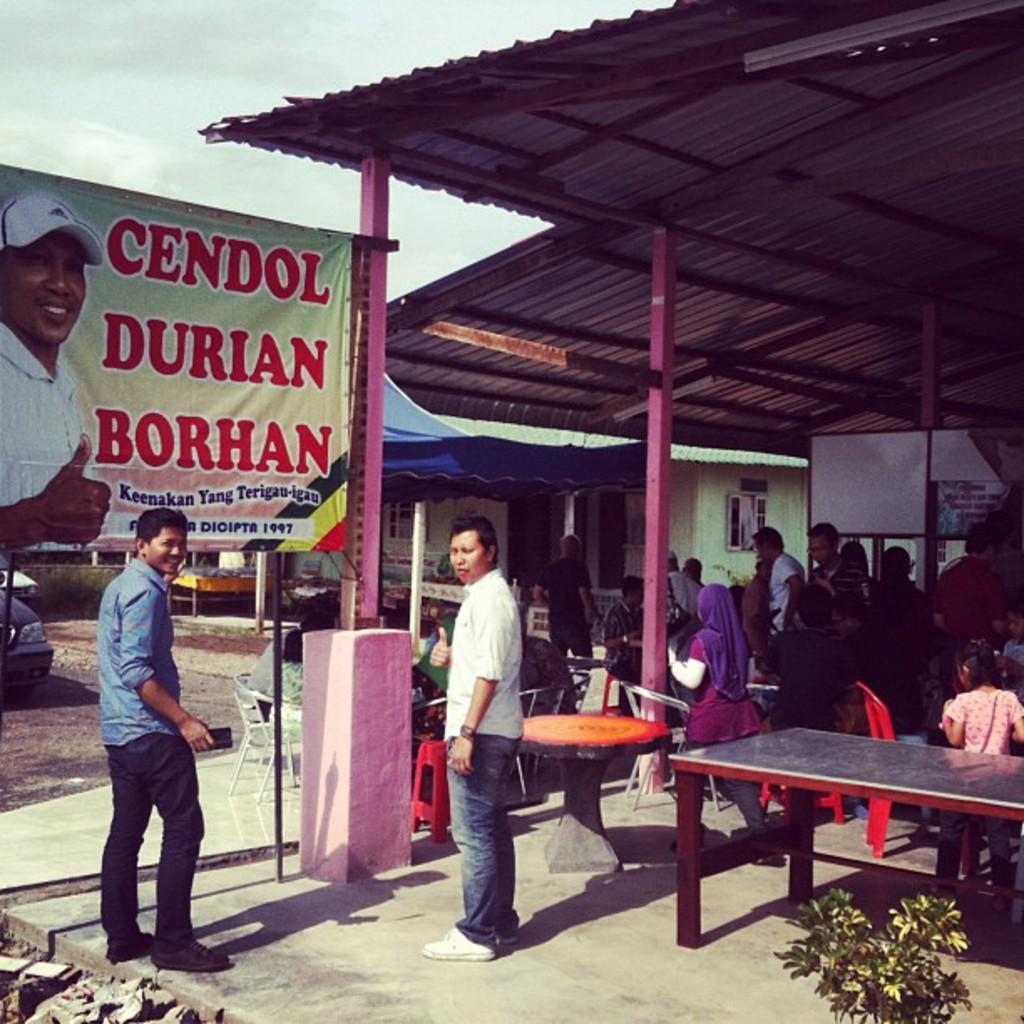Please provide a concise description of this image. In this image there are group of persons the man at the left side is standing and having smile on his face, the man standing in the center is smiling and the girl at the right side is standing. In the background the persons are sitting,walking and standing, there is a building, a tin shade, the clouds are full in the left side there is a banner with the name cendol durian borhan and there is a car at the left side at the right side there is a plant. 